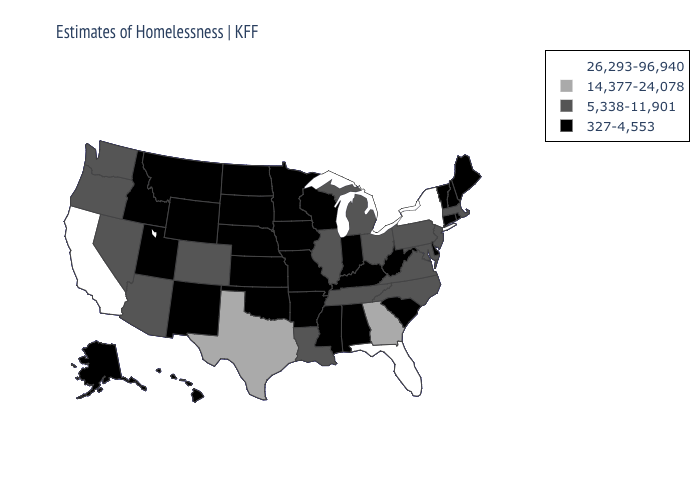Name the states that have a value in the range 14,377-24,078?
Short answer required. Georgia, Texas. How many symbols are there in the legend?
Short answer required. 4. Name the states that have a value in the range 5,338-11,901?
Concise answer only. Arizona, Colorado, Illinois, Louisiana, Maryland, Massachusetts, Michigan, Nevada, New Jersey, North Carolina, Ohio, Oregon, Pennsylvania, Tennessee, Virginia, Washington. What is the highest value in states that border Pennsylvania?
Short answer required. 26,293-96,940. What is the highest value in the MidWest ?
Keep it brief. 5,338-11,901. What is the value of South Carolina?
Short answer required. 327-4,553. What is the value of Hawaii?
Keep it brief. 327-4,553. What is the lowest value in states that border New York?
Quick response, please. 327-4,553. What is the value of West Virginia?
Short answer required. 327-4,553. Does New York have the highest value in the Northeast?
Quick response, please. Yes. Among the states that border Nebraska , does Colorado have the lowest value?
Give a very brief answer. No. What is the value of Colorado?
Answer briefly. 5,338-11,901. What is the highest value in states that border Massachusetts?
Concise answer only. 26,293-96,940. Does Missouri have the lowest value in the MidWest?
Short answer required. Yes. Among the states that border Massachusetts , does New York have the highest value?
Keep it brief. Yes. 